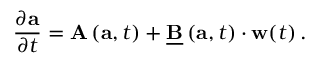<formula> <loc_0><loc_0><loc_500><loc_500>\frac { \partial a } { \partial t } = A \left ( a , t \right ) + \underline { B } \left ( a , t \right ) \cdot w ( t ) \, .</formula> 